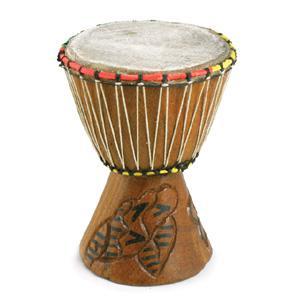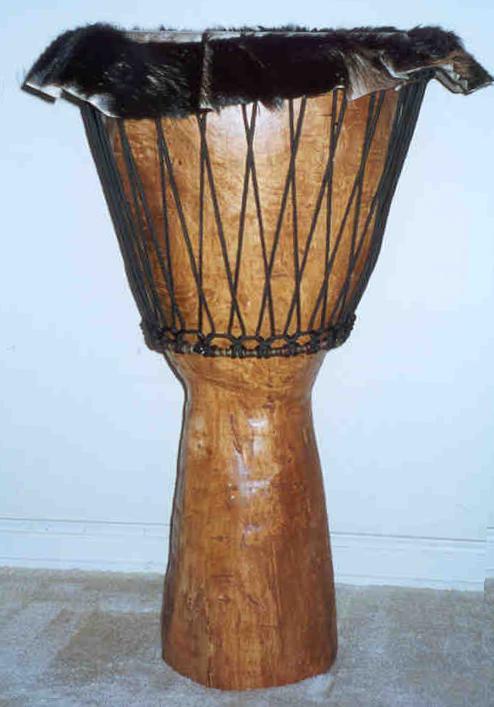The first image is the image on the left, the second image is the image on the right. Given the left and right images, does the statement "There are exactly two bongo drums." hold true? Answer yes or no. Yes. 